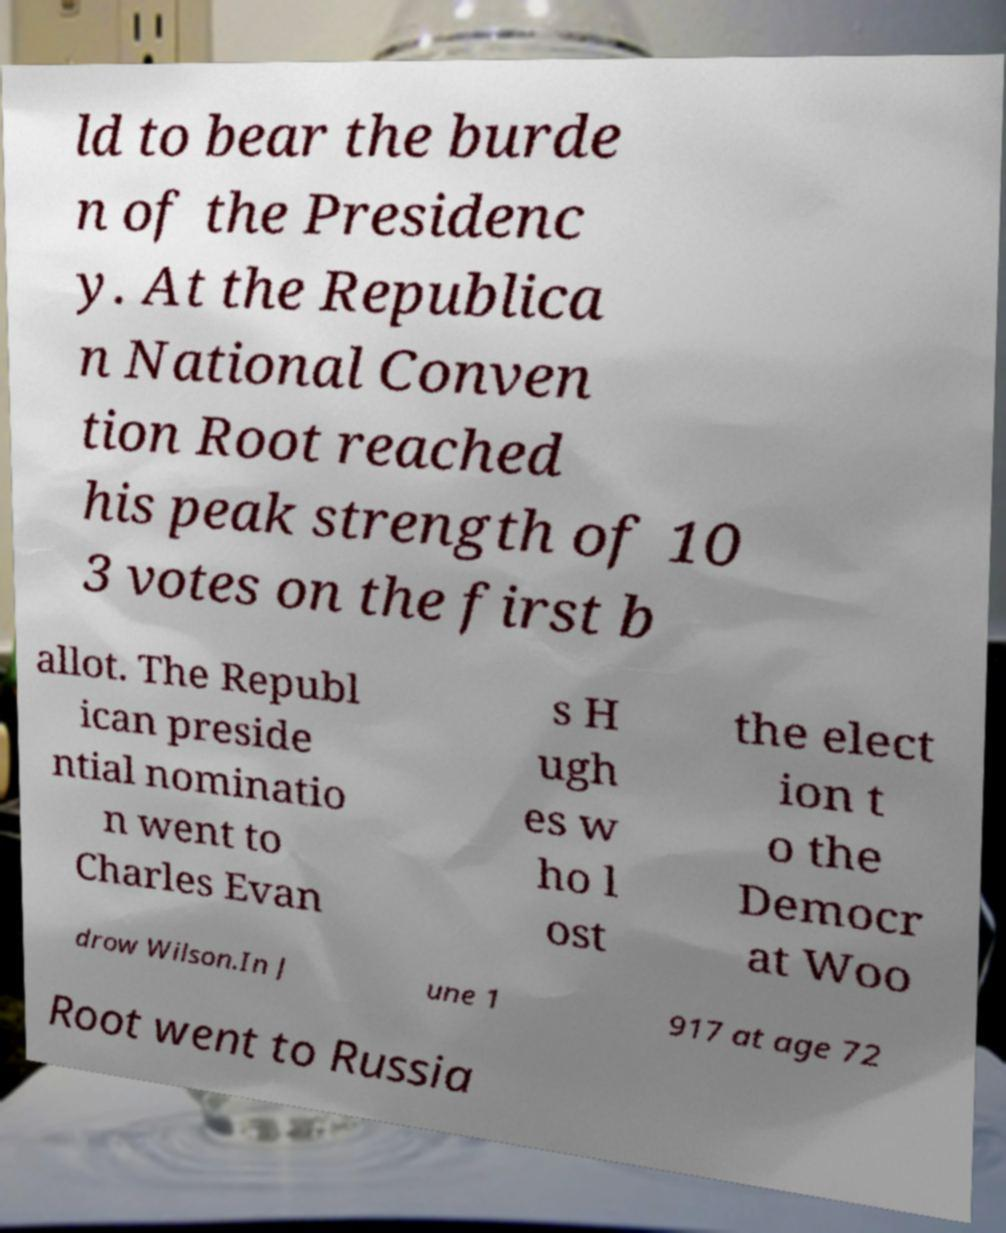There's text embedded in this image that I need extracted. Can you transcribe it verbatim? ld to bear the burde n of the Presidenc y. At the Republica n National Conven tion Root reached his peak strength of 10 3 votes on the first b allot. The Republ ican preside ntial nominatio n went to Charles Evan s H ugh es w ho l ost the elect ion t o the Democr at Woo drow Wilson.In J une 1 917 at age 72 Root went to Russia 